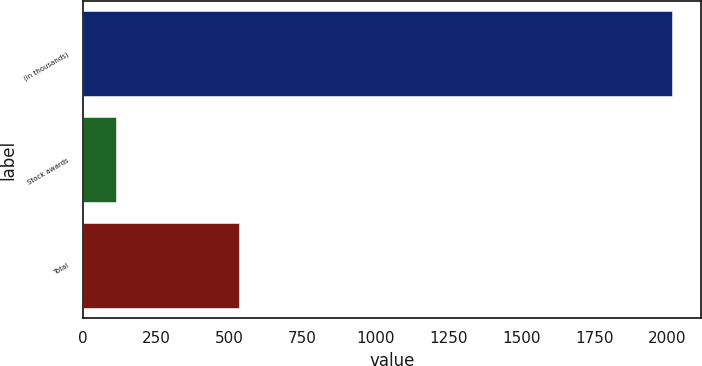Convert chart to OTSL. <chart><loc_0><loc_0><loc_500><loc_500><bar_chart><fcel>(in thousands)<fcel>Stock awards<fcel>Total<nl><fcel>2015<fcel>115<fcel>535<nl></chart> 